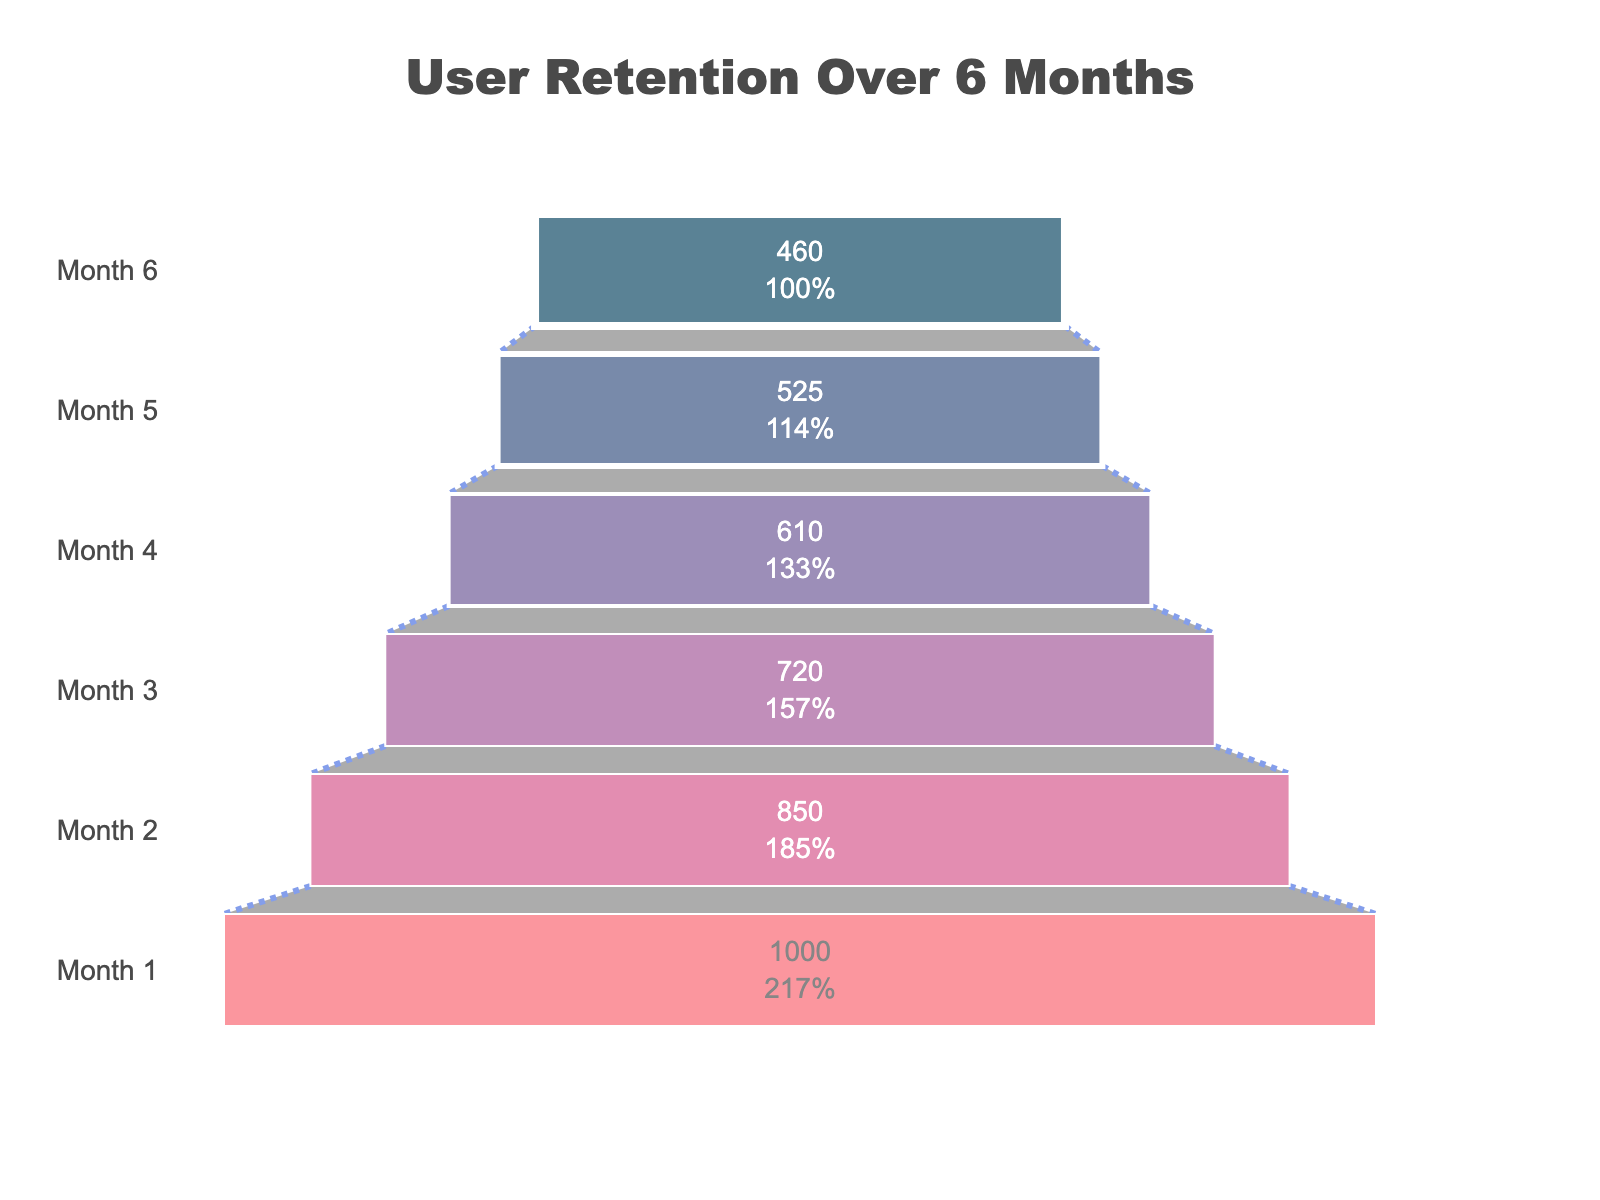What is the title of the chart? The chart’s title is displayed prominently at the top of the figure.
Answer: User Retention Over 6 Months Which month has the highest number of users? The highest value at the widest part of the funnel represents the month with the most users.
Answer: Month 1 What is the user count in Month 4? Refer to the specific label for Month 4 within the funnel chart to identify the number of users.
Answer: 610 By how many users did the count drop between Month 1 and Month 2? Subtract the user count in Month 2 from the user count in Month 1. Calculation: 1000 - 850.
Answer: 150 Which month has the smallest drop-off rate compared to the previous month? Compute the drop-off rate for each month by finding the difference between consecutive months and dividing it by the previous month’s user count. The month with the smallest result is the answer.
Answer: Month 5 Identify the month with the least number of users. The narrowest part of the funnel corresponds to the month with the lowest user count.
Answer: Month 6 What percentage of users were retained from Month 1 to Month 6? Calculate the percentage of users retained by dividing the users in Month 6 by the users in Month 1 multiplied by 100. Calculation: (460 / 1000) * 100.
Answer: 46% What’s the average number of users from Month 1 to Month 6? Sum the user counts for all six months and then divide by 6. Calculation: (1000 + 850 + 720 + 610 + 525 + 460) / 6.
Answer: 694.17 Which month saw the highest user drop-off in absolute numbers? Calculate the difference in user count between consecutive months and identify the month with the largest difference.
Answer: Month 1 to Month 2 Compare the user retention between Month 3 and Month 4. Is the retention rate higher for this period compared to the average monthly retention rate? Calculate the drop-off for each month to find the retention rate, then compute the average drop-off rate over all months. Compare the retention rate from Month 3 to Month 4 with this average.
Answer: No What’s the progression trend of user retention over the six months? Analyze the overall shape of the funnel and the individual user counts for each month to determine if the trend is consistent, increases, or decreases.
Answer: Decreasing 